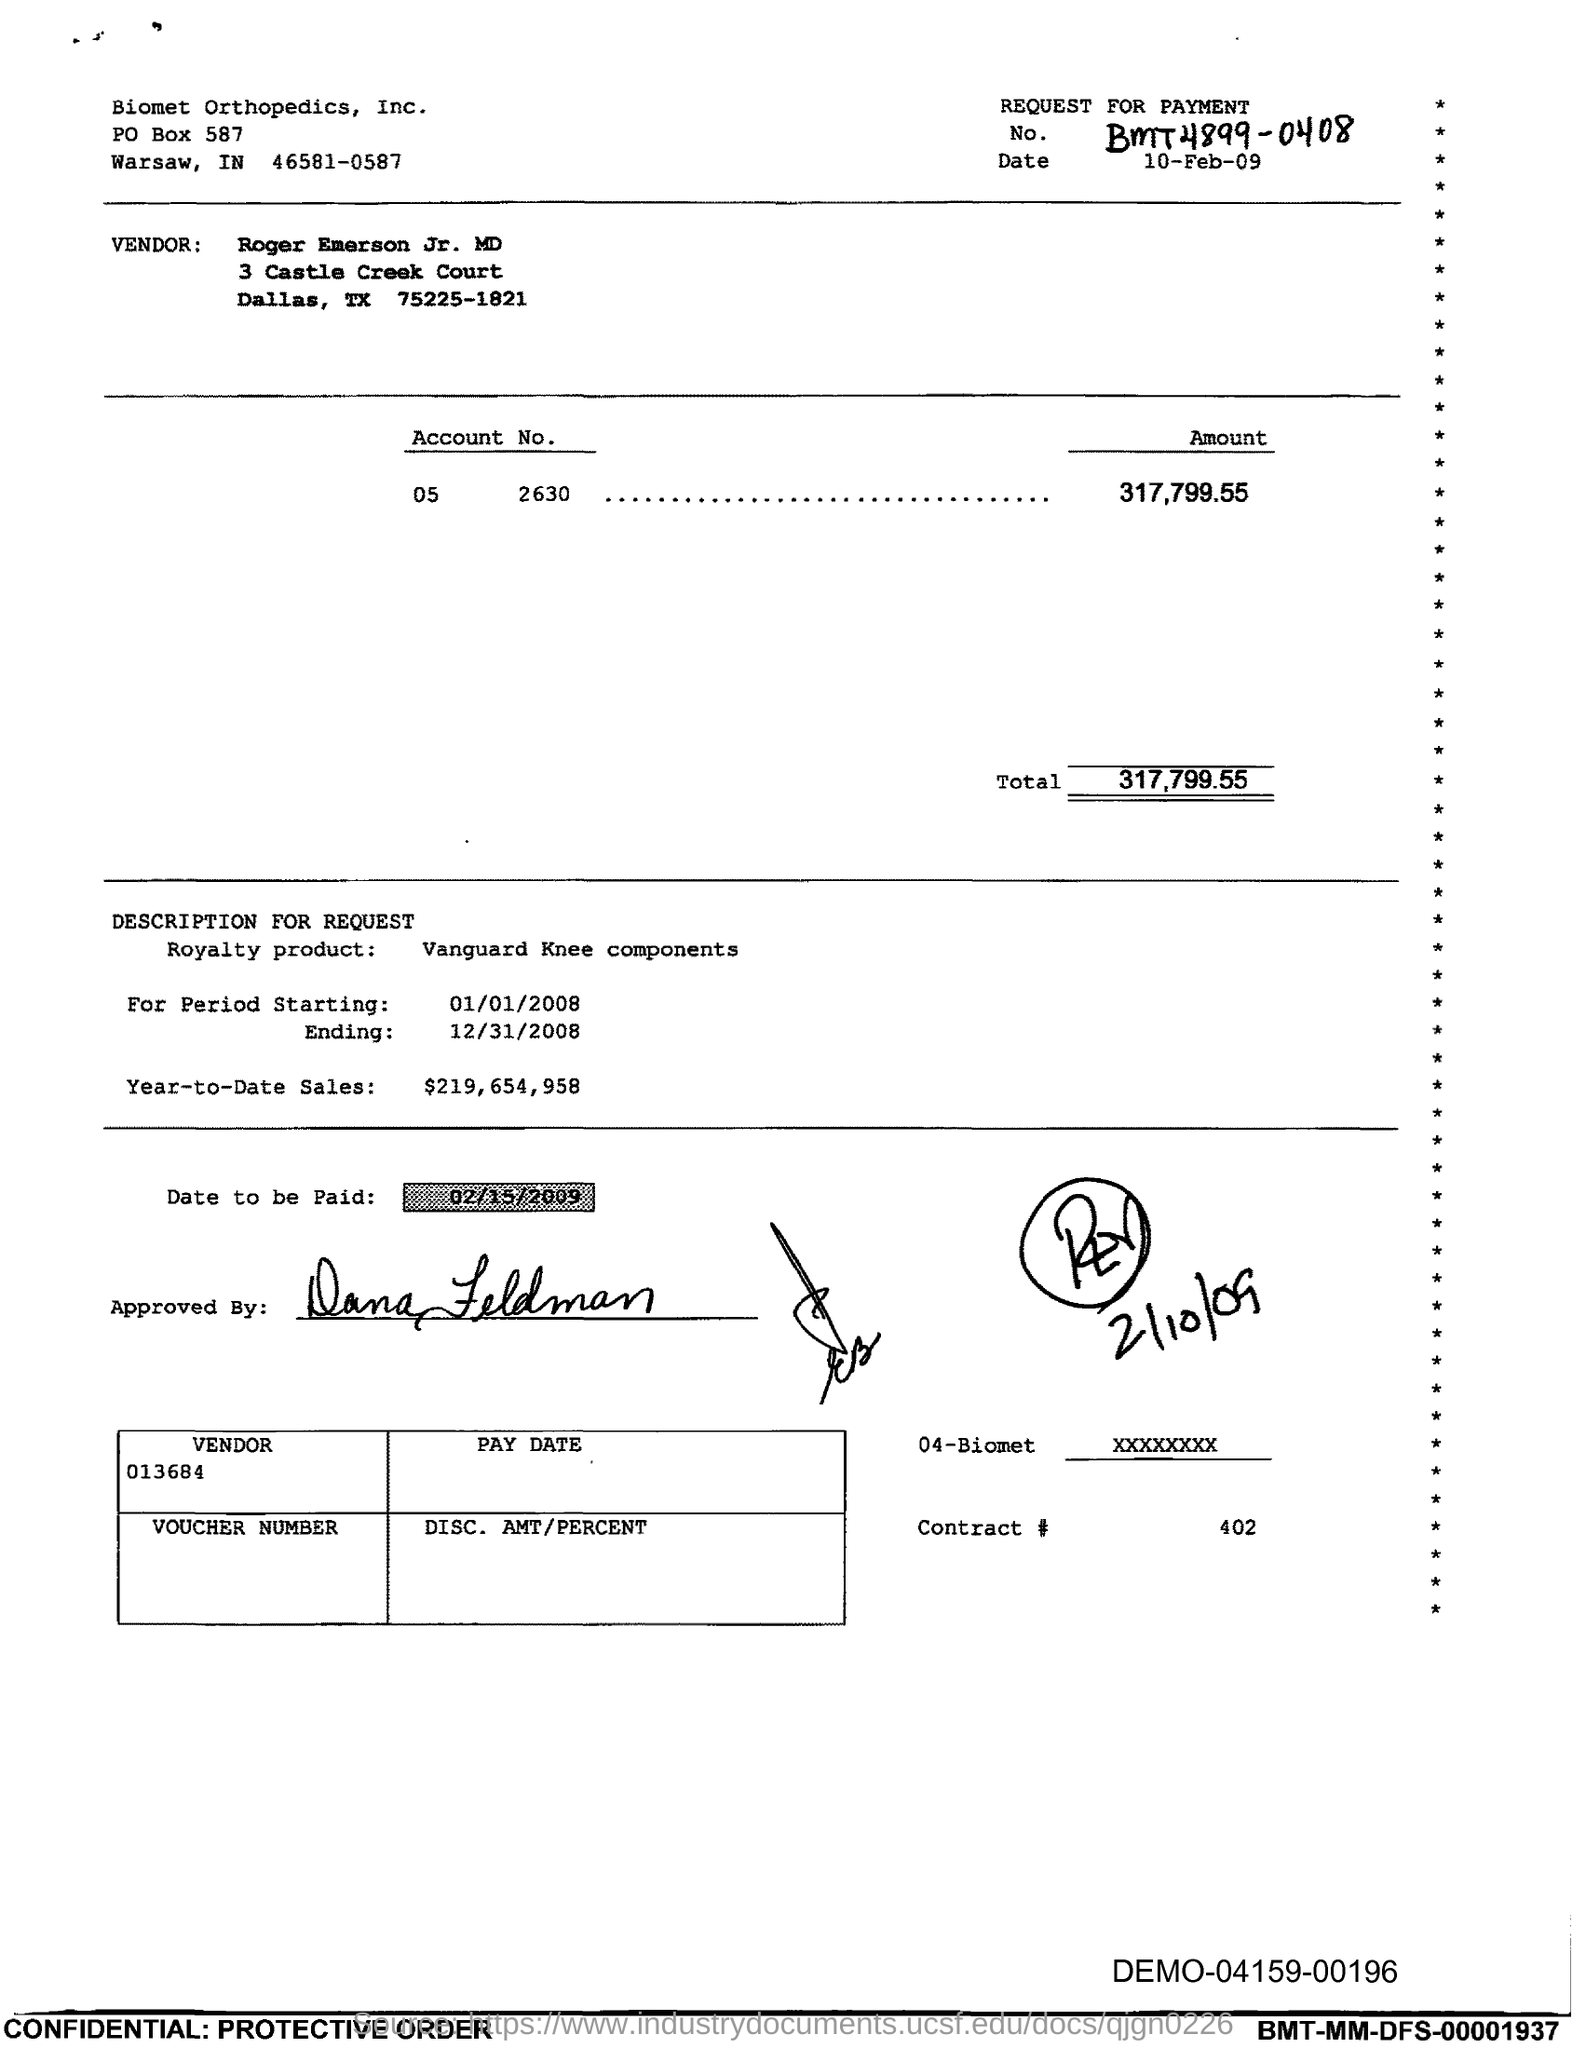What is the amount mentioned in the document?
Make the answer very short. 317,799.55. What is the 'date to be paid' mentioned in this document?
Provide a succinct answer. 02/15/2009. 